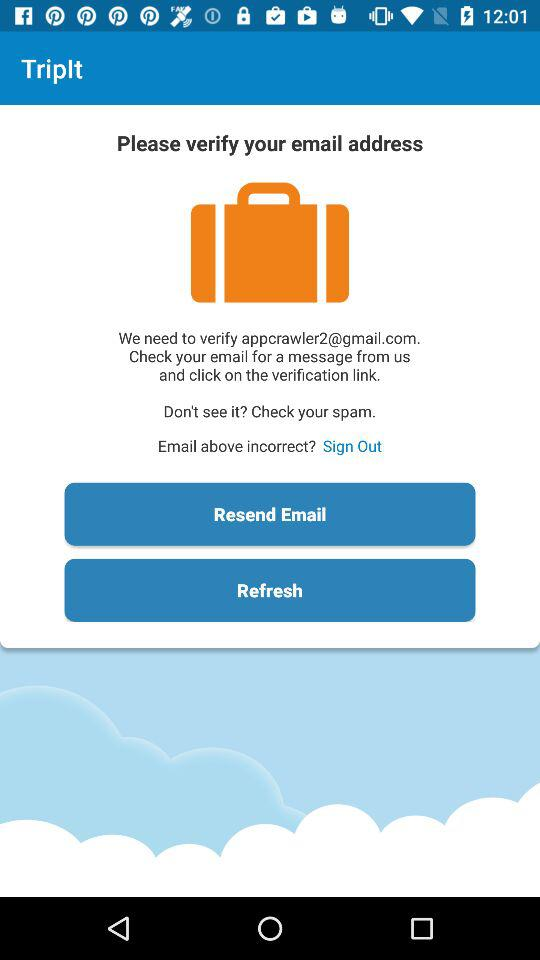What is the name of the application? The name of the application is "TripIt". 